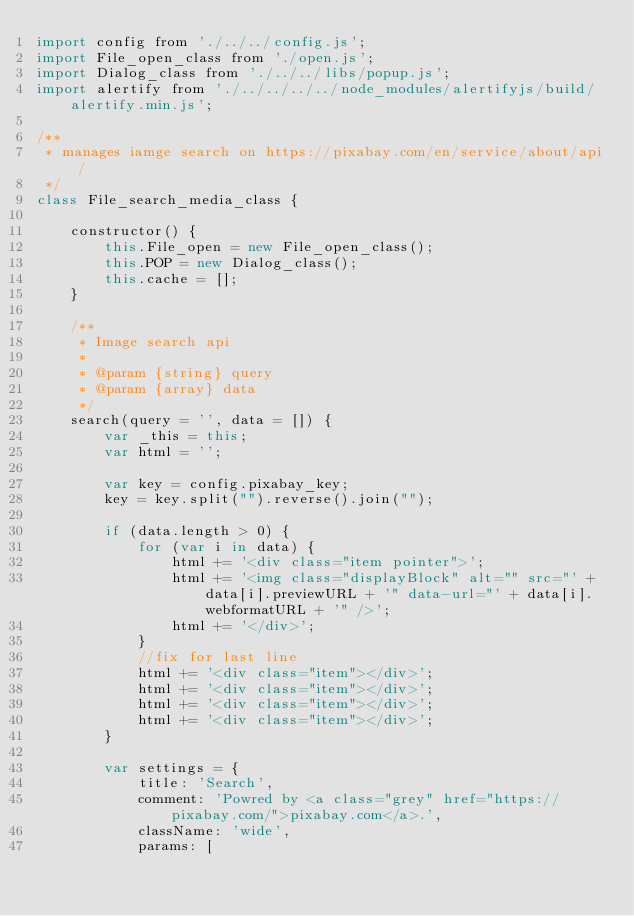<code> <loc_0><loc_0><loc_500><loc_500><_JavaScript_>import config from './../../config.js';
import File_open_class from './open.js';
import Dialog_class from './../../libs/popup.js';
import alertify from './../../../../node_modules/alertifyjs/build/alertify.min.js';

/** 
 * manages iamge search on https://pixabay.com/en/service/about/api/
 */
class File_search_media_class {

	constructor() {
		this.File_open = new File_open_class();
		this.POP = new Dialog_class();
		this.cache = [];
	}

	/**
	 * Image search api
	 * 
	 * @param {string} query
	 * @param {array} data
	 */
	search(query = '', data = []) {
		var _this = this;
		var html = '';

		var key = config.pixabay_key;
		key = key.split("").reverse().join("");

		if (data.length > 0) {
			for (var i in data) {
				html += '<div class="item pointer">';
				html += '<img class="displayBlock" alt="" src="' + data[i].previewURL + '" data-url="' + data[i].webformatURL + '" />';
				html += '</div>';
			}
			//fix for last line
			html += '<div class="item"></div>';
			html += '<div class="item"></div>';
			html += '<div class="item"></div>';
			html += '<div class="item"></div>';
		}

		var settings = {
			title: 'Search',
			comment: 'Powred by <a class="grey" href="https://pixabay.com/">pixabay.com</a>.',
			className: 'wide',
			params: [</code> 